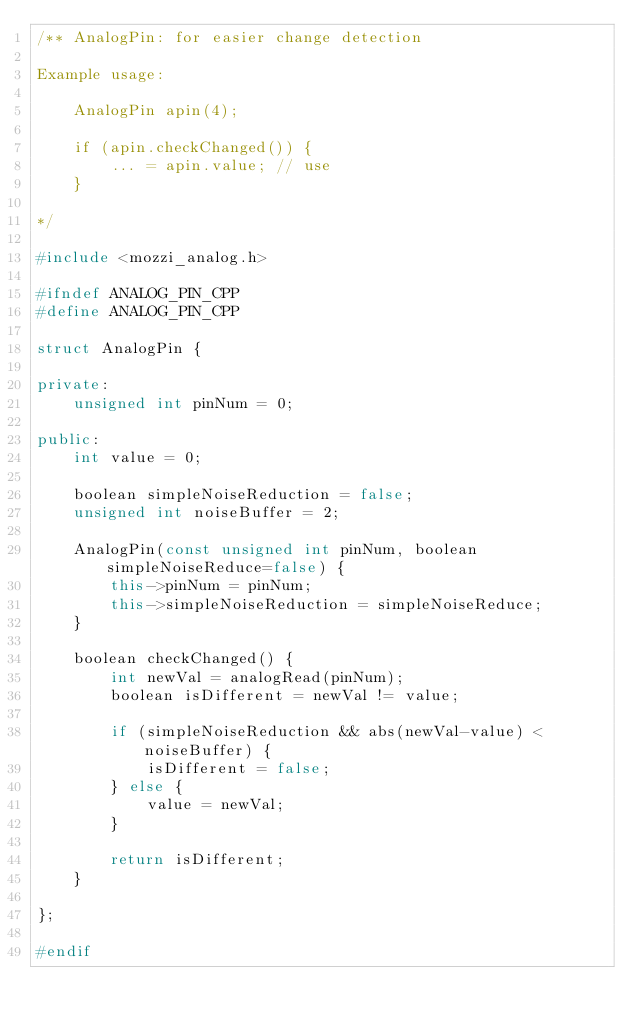Convert code to text. <code><loc_0><loc_0><loc_500><loc_500><_C++_>/** AnalogPin: for easier change detection

Example usage:

    AnalogPin apin(4);

    if (apin.checkChanged()) {
        ... = apin.value; // use
    }

*/

#include <mozzi_analog.h>

#ifndef ANALOG_PIN_CPP
#define ANALOG_PIN_CPP

struct AnalogPin {

private:
    unsigned int pinNum = 0;

public:
    int value = 0;

    boolean simpleNoiseReduction = false;
    unsigned int noiseBuffer = 2;

    AnalogPin(const unsigned int pinNum, boolean simpleNoiseReduce=false) {
        this->pinNum = pinNum;
        this->simpleNoiseReduction = simpleNoiseReduce;
    }

    boolean checkChanged() {
        int newVal = analogRead(pinNum);
        boolean isDifferent = newVal != value;

        if (simpleNoiseReduction && abs(newVal-value) < noiseBuffer) {
            isDifferent = false;
        } else {
            value = newVal;
        }

        return isDifferent;
    }

};

#endif
</code> 